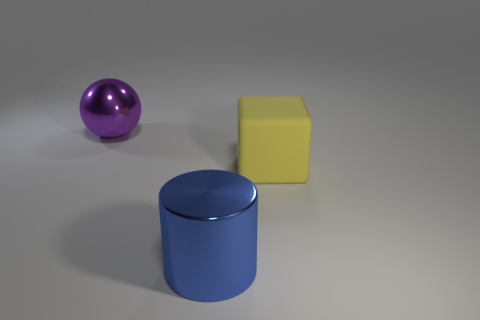What number of things are on the left side of the large yellow object and in front of the big purple object?
Your response must be concise. 1. Is there a big thing of the same color as the matte block?
Your response must be concise. No. There is a purple thing that is the same size as the blue thing; what is its shape?
Make the answer very short. Sphere. Are there any large yellow blocks behind the big yellow rubber cube?
Provide a short and direct response. No. Is the material of the big thing right of the big blue metal object the same as the large object that is in front of the large block?
Your answer should be very brief. No. How many yellow things are the same size as the metallic ball?
Make the answer very short. 1. What is the material of the thing in front of the big yellow object?
Your answer should be very brief. Metal. How many blue objects have the same shape as the big yellow thing?
Provide a succinct answer. 0. The large purple thing that is the same material as the large blue thing is what shape?
Your response must be concise. Sphere. There is a big shiny object that is behind the large metal thing that is in front of the metallic object that is behind the block; what shape is it?
Offer a very short reply. Sphere. 